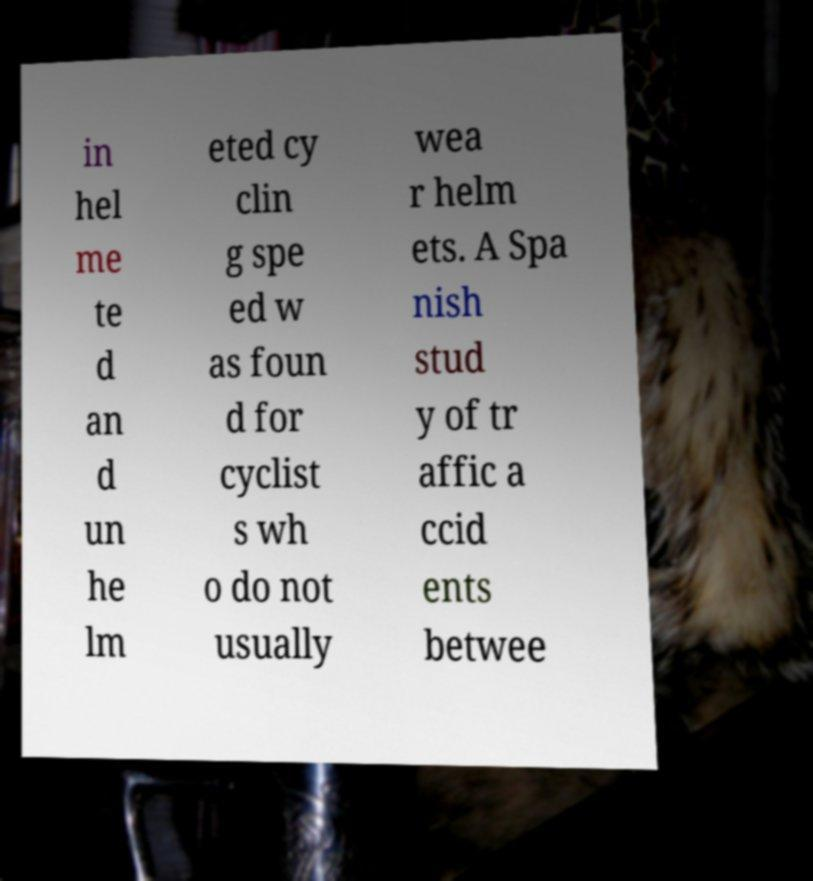Could you assist in decoding the text presented in this image and type it out clearly? in hel me te d an d un he lm eted cy clin g spe ed w as foun d for cyclist s wh o do not usually wea r helm ets. A Spa nish stud y of tr affic a ccid ents betwee 